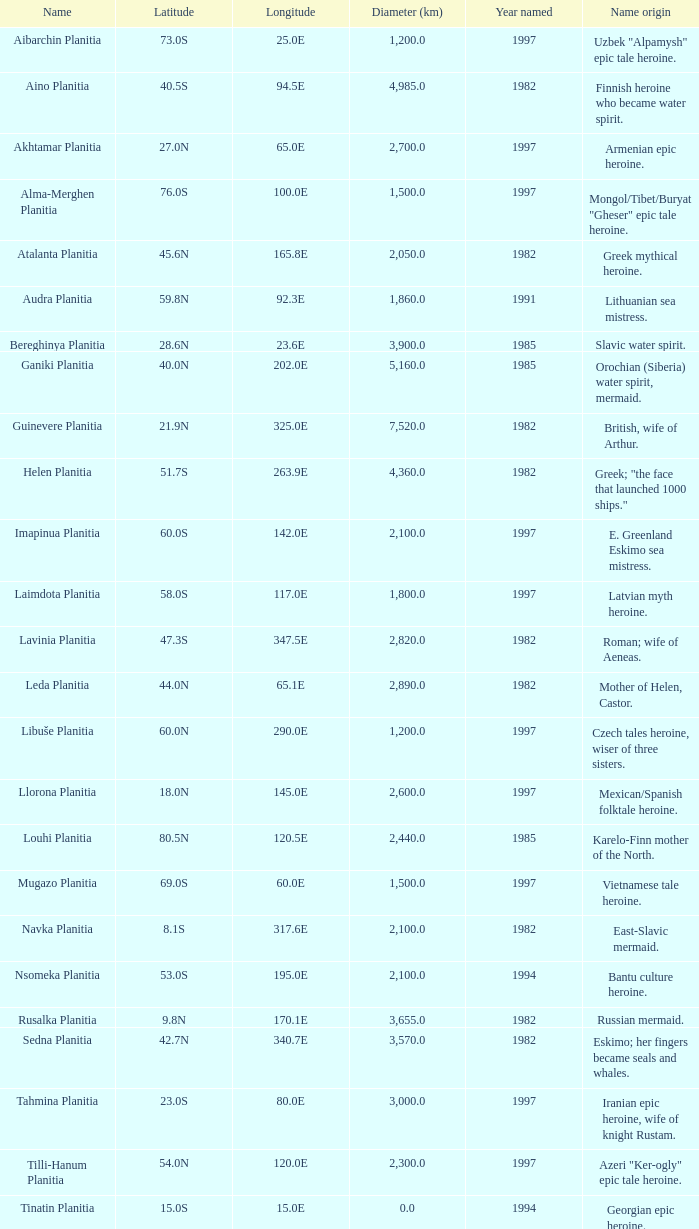Can you give me this table as a dict? {'header': ['Name', 'Latitude', 'Longitude', 'Diameter (km)', 'Year named', 'Name origin'], 'rows': [['Aibarchin Planitia', '73.0S', '25.0E', '1,200.0', '1997', 'Uzbek "Alpamysh" epic tale heroine.'], ['Aino Planitia', '40.5S', '94.5E', '4,985.0', '1982', 'Finnish heroine who became water spirit.'], ['Akhtamar Planitia', '27.0N', '65.0E', '2,700.0', '1997', 'Armenian epic heroine.'], ['Alma-Merghen Planitia', '76.0S', '100.0E', '1,500.0', '1997', 'Mongol/Tibet/Buryat "Gheser" epic tale heroine.'], ['Atalanta Planitia', '45.6N', '165.8E', '2,050.0', '1982', 'Greek mythical heroine.'], ['Audra Planitia', '59.8N', '92.3E', '1,860.0', '1991', 'Lithuanian sea mistress.'], ['Bereghinya Planitia', '28.6N', '23.6E', '3,900.0', '1985', 'Slavic water spirit.'], ['Ganiki Planitia', '40.0N', '202.0E', '5,160.0', '1985', 'Orochian (Siberia) water spirit, mermaid.'], ['Guinevere Planitia', '21.9N', '325.0E', '7,520.0', '1982', 'British, wife of Arthur.'], ['Helen Planitia', '51.7S', '263.9E', '4,360.0', '1982', 'Greek; "the face that launched 1000 ships."'], ['Imapinua Planitia', '60.0S', '142.0E', '2,100.0', '1997', 'E. Greenland Eskimo sea mistress.'], ['Laimdota Planitia', '58.0S', '117.0E', '1,800.0', '1997', 'Latvian myth heroine.'], ['Lavinia Planitia', '47.3S', '347.5E', '2,820.0', '1982', 'Roman; wife of Aeneas.'], ['Leda Planitia', '44.0N', '65.1E', '2,890.0', '1982', 'Mother of Helen, Castor.'], ['Libuše Planitia', '60.0N', '290.0E', '1,200.0', '1997', 'Czech tales heroine, wiser of three sisters.'], ['Llorona Planitia', '18.0N', '145.0E', '2,600.0', '1997', 'Mexican/Spanish folktale heroine.'], ['Louhi Planitia', '80.5N', '120.5E', '2,440.0', '1985', 'Karelo-Finn mother of the North.'], ['Mugazo Planitia', '69.0S', '60.0E', '1,500.0', '1997', 'Vietnamese tale heroine.'], ['Navka Planitia', '8.1S', '317.6E', '2,100.0', '1982', 'East-Slavic mermaid.'], ['Nsomeka Planitia', '53.0S', '195.0E', '2,100.0', '1994', 'Bantu culture heroine.'], ['Rusalka Planitia', '9.8N', '170.1E', '3,655.0', '1982', 'Russian mermaid.'], ['Sedna Planitia', '42.7N', '340.7E', '3,570.0', '1982', 'Eskimo; her fingers became seals and whales.'], ['Tahmina Planitia', '23.0S', '80.0E', '3,000.0', '1997', 'Iranian epic heroine, wife of knight Rustam.'], ['Tilli-Hanum Planitia', '54.0N', '120.0E', '2,300.0', '1997', 'Azeri "Ker-ogly" epic tale heroine.'], ['Tinatin Planitia', '15.0S', '15.0E', '0.0', '1994', 'Georgian epic heroine.'], ['Undine Planitia', '13.0N', '303.0E', '2,800.0', '1997', 'Lithuanian water nymph, mermaid.'], ['Vellamo Planitia', '45.4N', '149.1E', '2,155.0', '1985', 'Karelo-Finn mermaid.']]} 1e? 3655.0. 